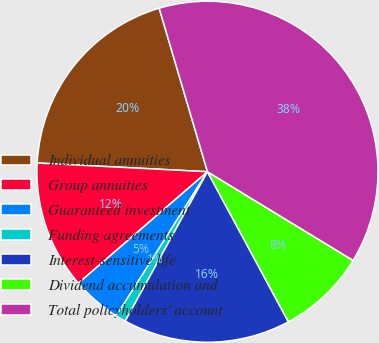<chart> <loc_0><loc_0><loc_500><loc_500><pie_chart><fcel>Individual annuities<fcel>Group annuities<fcel>Guaranteed investment<fcel>Funding agreements<fcel>Interest-sensitive life<fcel>Dividend accumulation and<fcel>Total policyholders' account<nl><fcel>19.61%<fcel>12.15%<fcel>4.69%<fcel>0.96%<fcel>15.88%<fcel>8.42%<fcel>38.27%<nl></chart> 